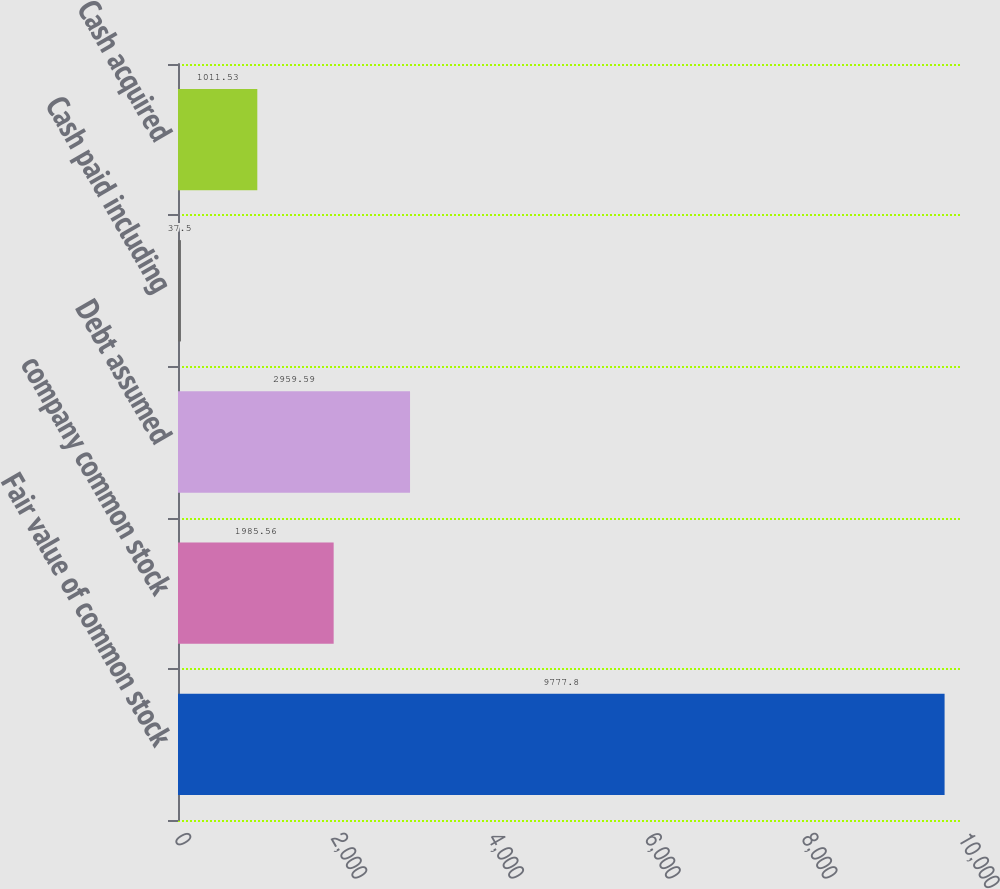Convert chart to OTSL. <chart><loc_0><loc_0><loc_500><loc_500><bar_chart><fcel>Fair value of common stock<fcel>company common stock<fcel>Debt assumed<fcel>Cash paid including<fcel>Cash acquired<nl><fcel>9777.8<fcel>1985.56<fcel>2959.59<fcel>37.5<fcel>1011.53<nl></chart> 